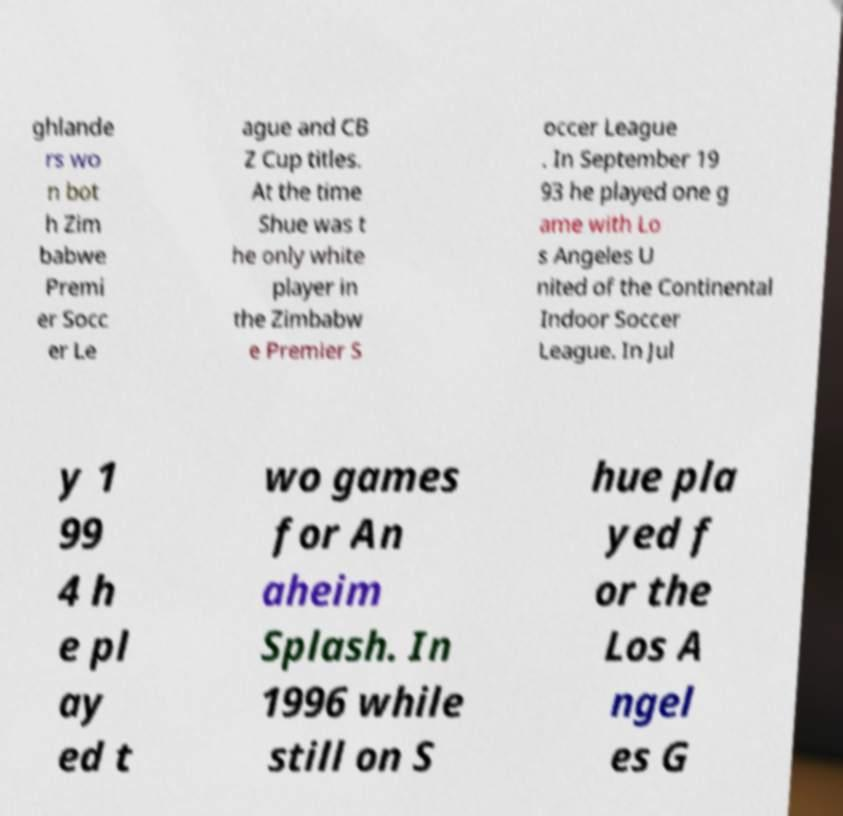There's text embedded in this image that I need extracted. Can you transcribe it verbatim? ghlande rs wo n bot h Zim babwe Premi er Socc er Le ague and CB Z Cup titles. At the time Shue was t he only white player in the Zimbabw e Premier S occer League . In September 19 93 he played one g ame with Lo s Angeles U nited of the Continental Indoor Soccer League. In Jul y 1 99 4 h e pl ay ed t wo games for An aheim Splash. In 1996 while still on S hue pla yed f or the Los A ngel es G 